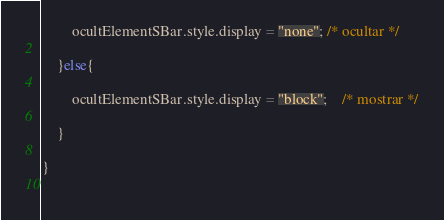Convert code to text. <code><loc_0><loc_0><loc_500><loc_500><_JavaScript_>		ocultElementSBar.style.display = "none"; /* ocultar */
		
	}else{
		
		ocultElementSBar.style.display = "block";	/* mostrar */
		
	}
	
}
	









</code> 